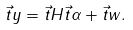<formula> <loc_0><loc_0><loc_500><loc_500>\vec { t } { y } = \vec { t } { H } \vec { t } { \alpha } + \vec { t } { w } .</formula> 